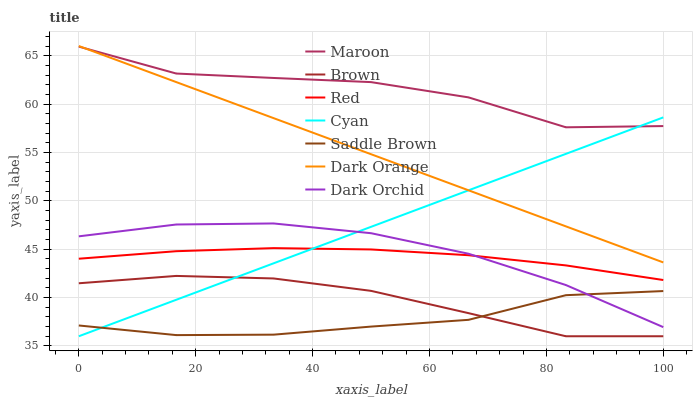Does Saddle Brown have the minimum area under the curve?
Answer yes or no. Yes. Does Maroon have the maximum area under the curve?
Answer yes or no. Yes. Does Dark Orange have the minimum area under the curve?
Answer yes or no. No. Does Dark Orange have the maximum area under the curve?
Answer yes or no. No. Is Cyan the smoothest?
Answer yes or no. Yes. Is Maroon the roughest?
Answer yes or no. Yes. Is Dark Orange the smoothest?
Answer yes or no. No. Is Dark Orange the roughest?
Answer yes or no. No. Does Brown have the lowest value?
Answer yes or no. Yes. Does Dark Orange have the lowest value?
Answer yes or no. No. Does Dark Orange have the highest value?
Answer yes or no. Yes. Does Maroon have the highest value?
Answer yes or no. No. Is Brown less than Dark Orchid?
Answer yes or no. Yes. Is Dark Orange greater than Red?
Answer yes or no. Yes. Does Saddle Brown intersect Cyan?
Answer yes or no. Yes. Is Saddle Brown less than Cyan?
Answer yes or no. No. Is Saddle Brown greater than Cyan?
Answer yes or no. No. Does Brown intersect Dark Orchid?
Answer yes or no. No. 